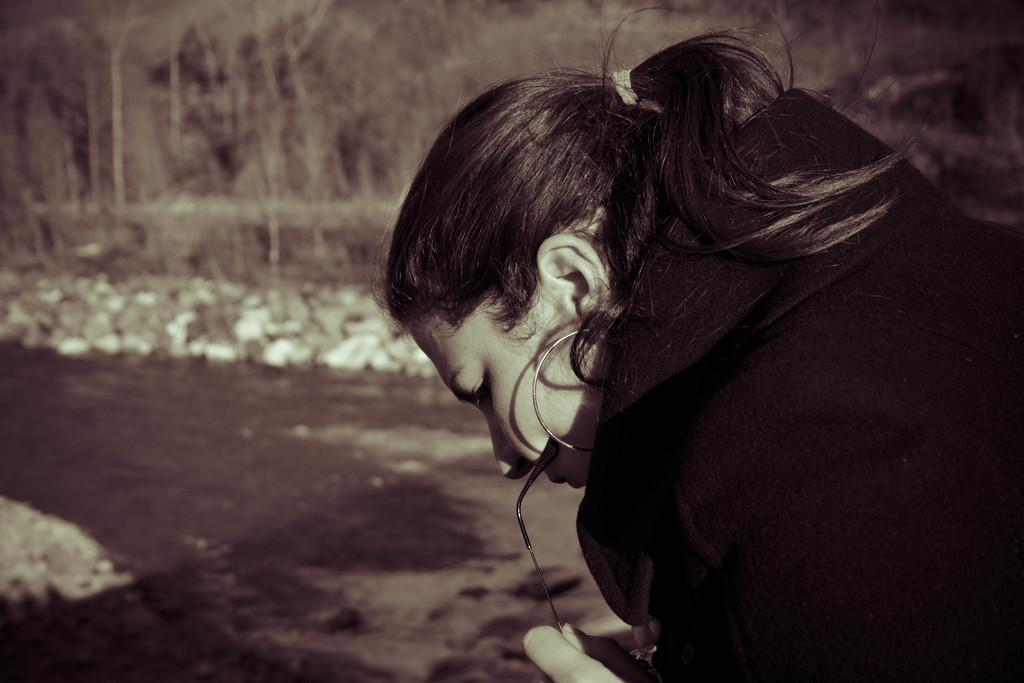Who is present in the image? There is a woman in the image. What can be seen in the background of the image? There are trees behind the woman in the image. What type of chess piece is the woman holding in the image? There is no chess piece present in the image; the woman is not holding anything. 